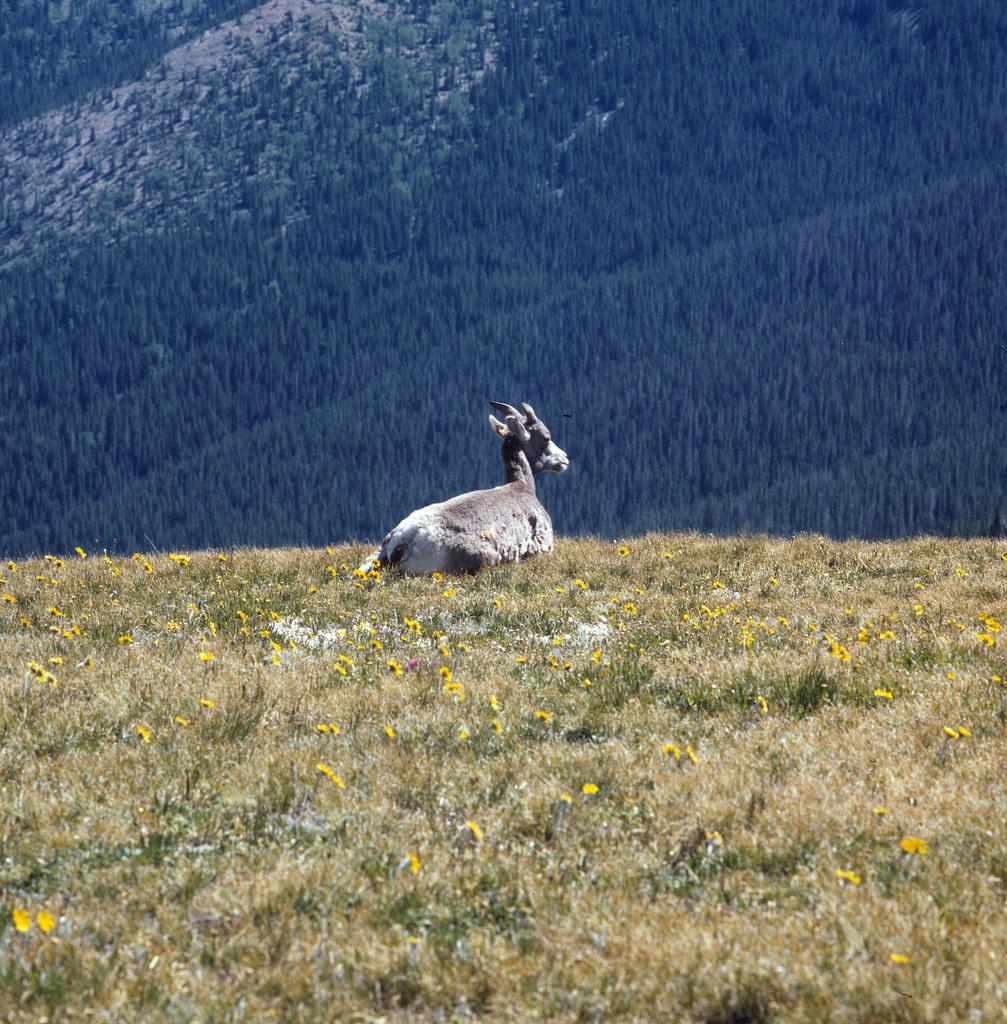What is the main subject in the center of the image? There is an animal in the center of the image. What is the animal sitting on? The animal is sitting on the grass. What type of vegetation can be seen in the image? There are flowers visible in the image. What can be seen in the background of the image? There is a hill visible in the background of the image. What type of underwear is the animal wearing in the image? There is no underwear visible in the image, as it features an animal sitting on the grass with flowers and a hill in the background. 